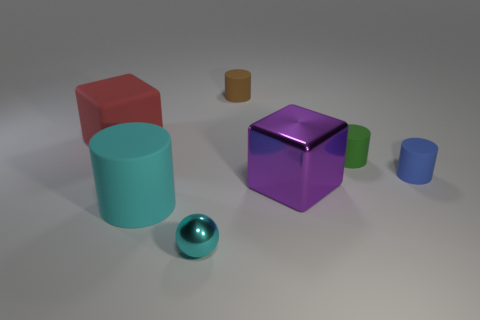Subtract all green cylinders. How many cylinders are left? 3 Add 1 tiny rubber objects. How many objects exist? 8 Subtract all red cylinders. Subtract all red blocks. How many cylinders are left? 4 Subtract all cylinders. How many objects are left? 3 Add 7 large green matte cylinders. How many large green matte cylinders exist? 7 Subtract 1 purple cubes. How many objects are left? 6 Subtract all cubes. Subtract all cylinders. How many objects are left? 1 Add 1 tiny green things. How many tiny green things are left? 2 